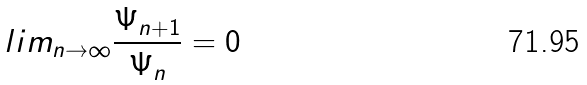Convert formula to latex. <formula><loc_0><loc_0><loc_500><loc_500>l i m _ { n \rightarrow \infty } \frac { \Psi _ { n + 1 } } { \Psi _ { n } } = 0</formula> 